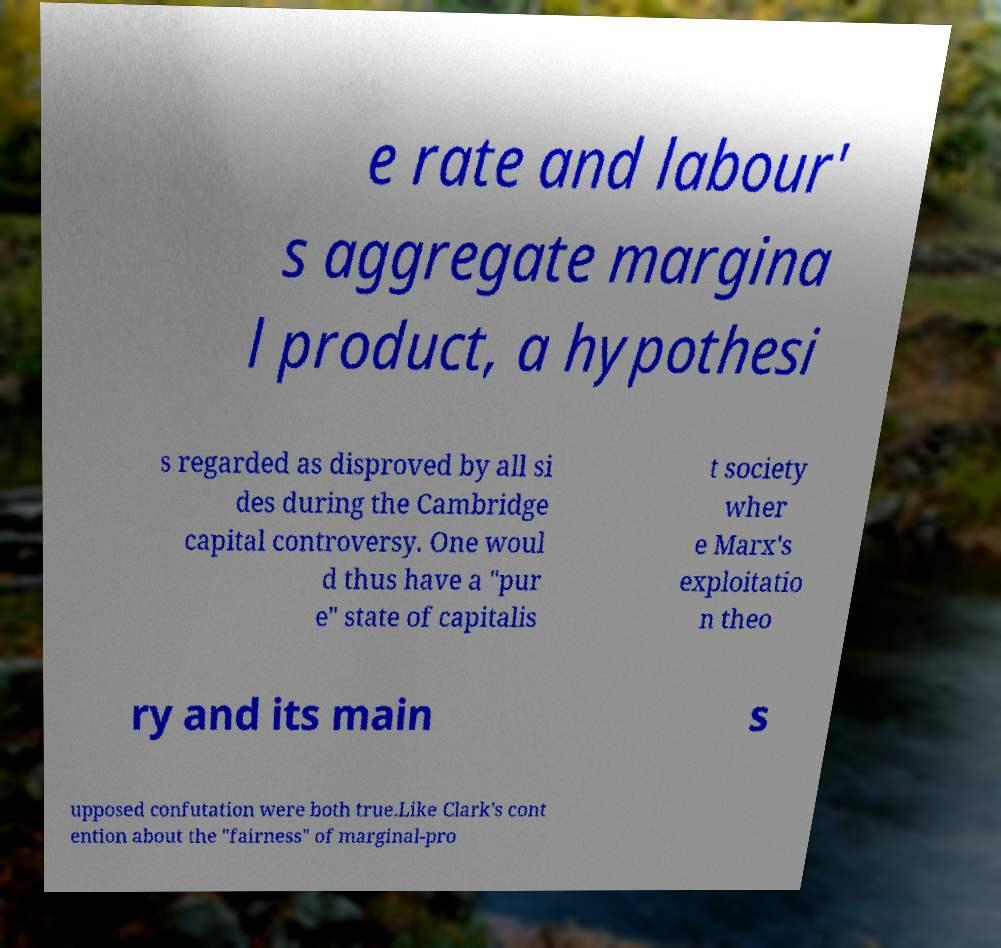For documentation purposes, I need the text within this image transcribed. Could you provide that? e rate and labour' s aggregate margina l product, a hypothesi s regarded as disproved by all si des during the Cambridge capital controversy. One woul d thus have a "pur e" state of capitalis t society wher e Marx's exploitatio n theo ry and its main s upposed confutation were both true.Like Clark's cont ention about the "fairness" of marginal-pro 